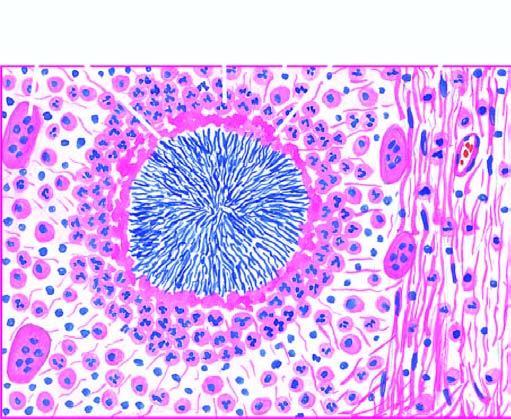what does the margin of the colony show?
Answer the question using a single word or phrase. Hyaline filaments highlighted by masson 's trichrome stain right photomicrograph 